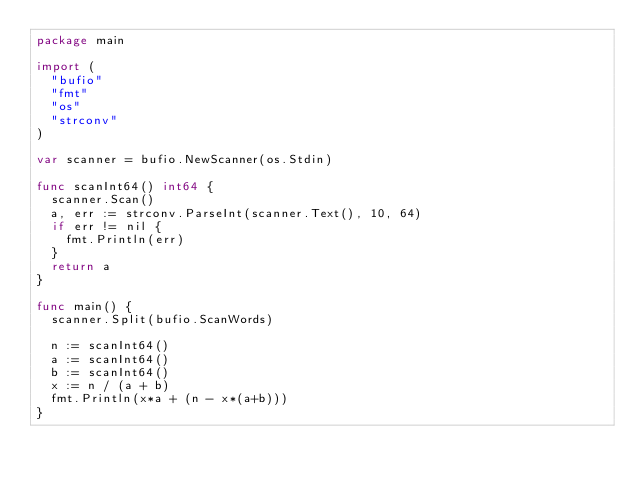Convert code to text. <code><loc_0><loc_0><loc_500><loc_500><_Go_>package main

import (
	"bufio"
	"fmt"
	"os"
	"strconv"
)

var scanner = bufio.NewScanner(os.Stdin)

func scanInt64() int64 {
	scanner.Scan()
	a, err := strconv.ParseInt(scanner.Text(), 10, 64)
	if err != nil {
		fmt.Println(err)
	}
	return a
}

func main() {
	scanner.Split(bufio.ScanWords)

	n := scanInt64()
	a := scanInt64()
	b := scanInt64()
	x := n / (a + b)
	fmt.Println(x*a + (n - x*(a+b)))
}</code> 